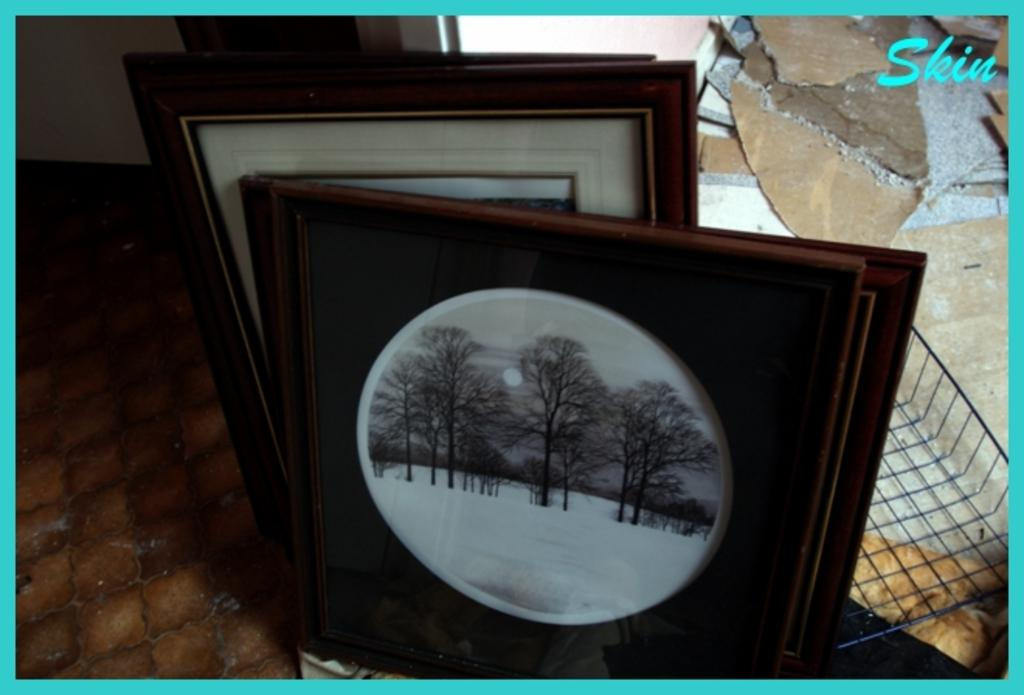What objects are on the floor in the image? There are photo frames on the floor. How are the photo frames arranged? The photo frames are arranged one after the other. Where are the photo frames located in relation to the wall? The photo frames are beside a wall. What type of cooking equipment is visible in the image? There is an iron grill pan in the image. What can be seen at the top of the image? There is some text at the top of the image. What type of baseball equipment can be seen in the image? There is no baseball equipment present in the image. What type of business is being conducted in the image? The image does not depict any business activity. 